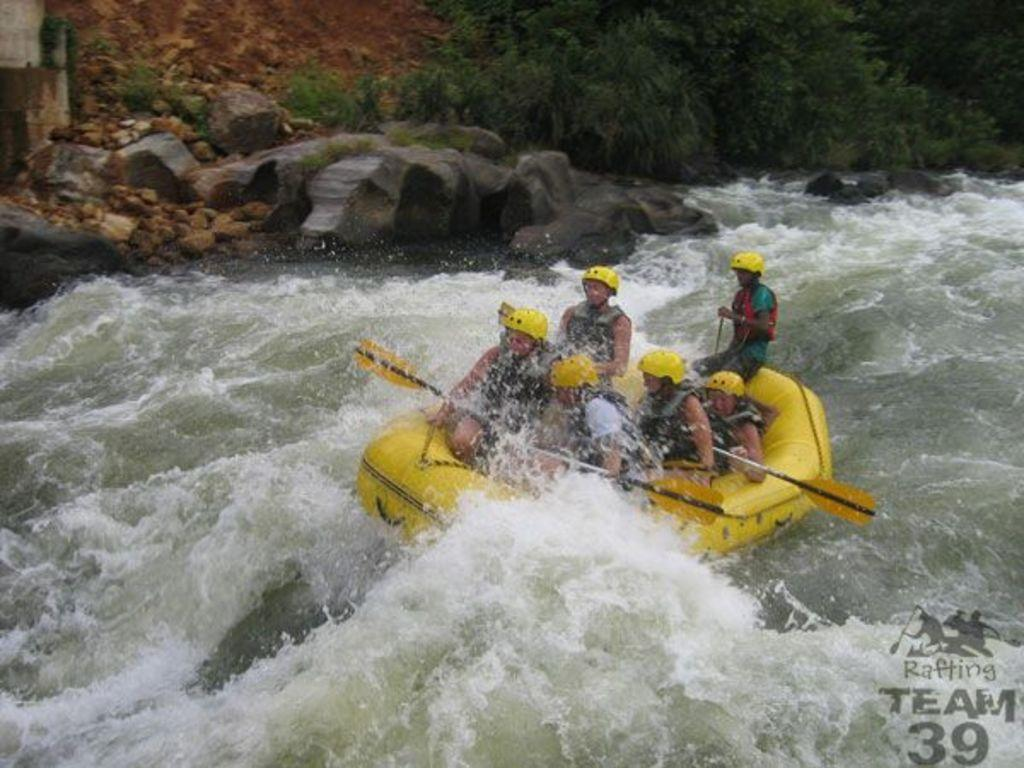What are the persons in the image doing? The persons in the image are riding a boat. What type of environment is visible in the image? There is water visible in the image. What can be seen in the background of the image? Rocks and trees are visible in the background of the image. What type of bird can be seen perched on the wall in the image? There is no wall present in the image, and therefore no bird perched on it. How many wrens are swimming in the water in the image? There is no mention of wrens or any other birds in the image; it only features persons riding a boat. 